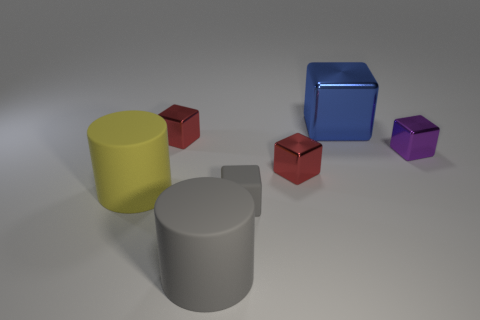Subtract all purple blocks. How many blocks are left? 4 Subtract all gray blocks. How many blocks are left? 4 Subtract all green blocks. Subtract all brown cylinders. How many blocks are left? 5 Add 1 large rubber cylinders. How many objects exist? 8 Subtract all blocks. How many objects are left? 2 Subtract all large cyan cylinders. Subtract all yellow rubber cylinders. How many objects are left? 6 Add 2 large gray cylinders. How many large gray cylinders are left? 3 Add 4 tiny red matte spheres. How many tiny red matte spheres exist? 4 Subtract 0 blue balls. How many objects are left? 7 